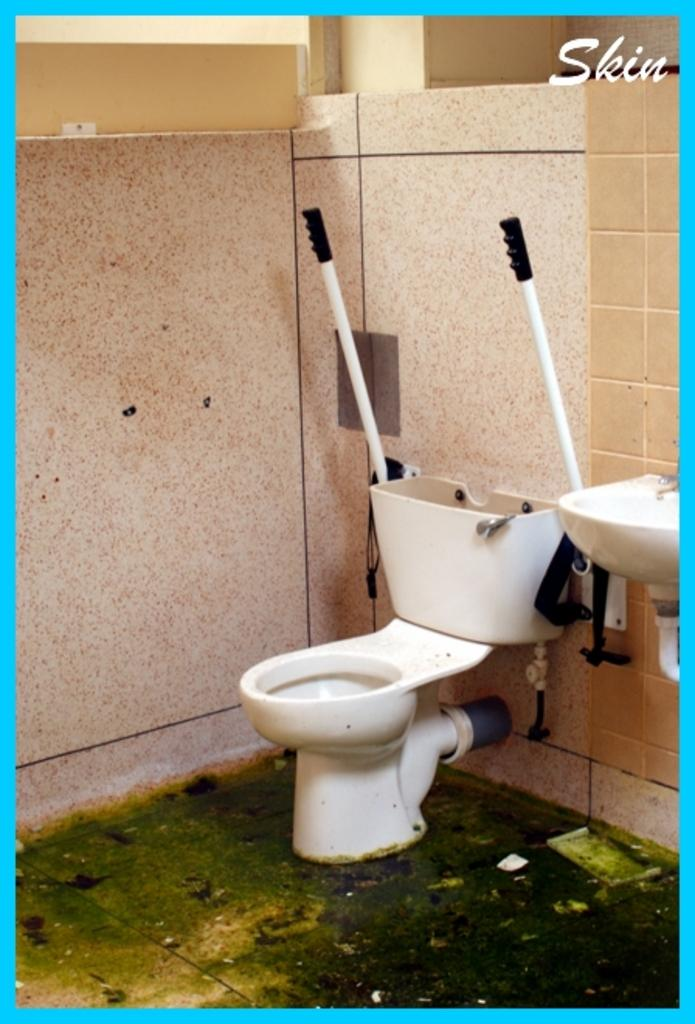What is the main object in the image? There is a toilet seat in the image. What can be seen in the background of the image? There are walls visible in the background of the image. Where is the text located in the image? The text is present in the top right hand side of the image. What type of copper material is used to make the toilet seat in the image? There is no mention of copper or any specific material used to make the toilet seat in the image. 